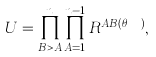<formula> <loc_0><loc_0><loc_500><loc_500>U = \prod _ { B > A } ^ { n } \prod _ { A = 1 } ^ { n - 1 } R ^ { A B ( \theta _ { A B } ) } ,</formula> 